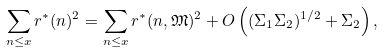<formula> <loc_0><loc_0><loc_500><loc_500>\sum _ { n \leq x } r ^ { * } ( n ) ^ { 2 } = \sum _ { n \leq x } r ^ { * } ( n , \mathfrak M ) ^ { 2 } + O \left ( ( \Sigma _ { 1 } \Sigma _ { 2 } ) ^ { 1 / 2 } + \Sigma _ { 2 } \right ) ,</formula> 